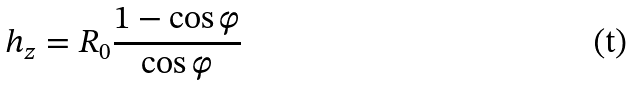Convert formula to latex. <formula><loc_0><loc_0><loc_500><loc_500>h _ { z } = R _ { 0 } \frac { 1 - \cos \varphi } { \cos \varphi }</formula> 